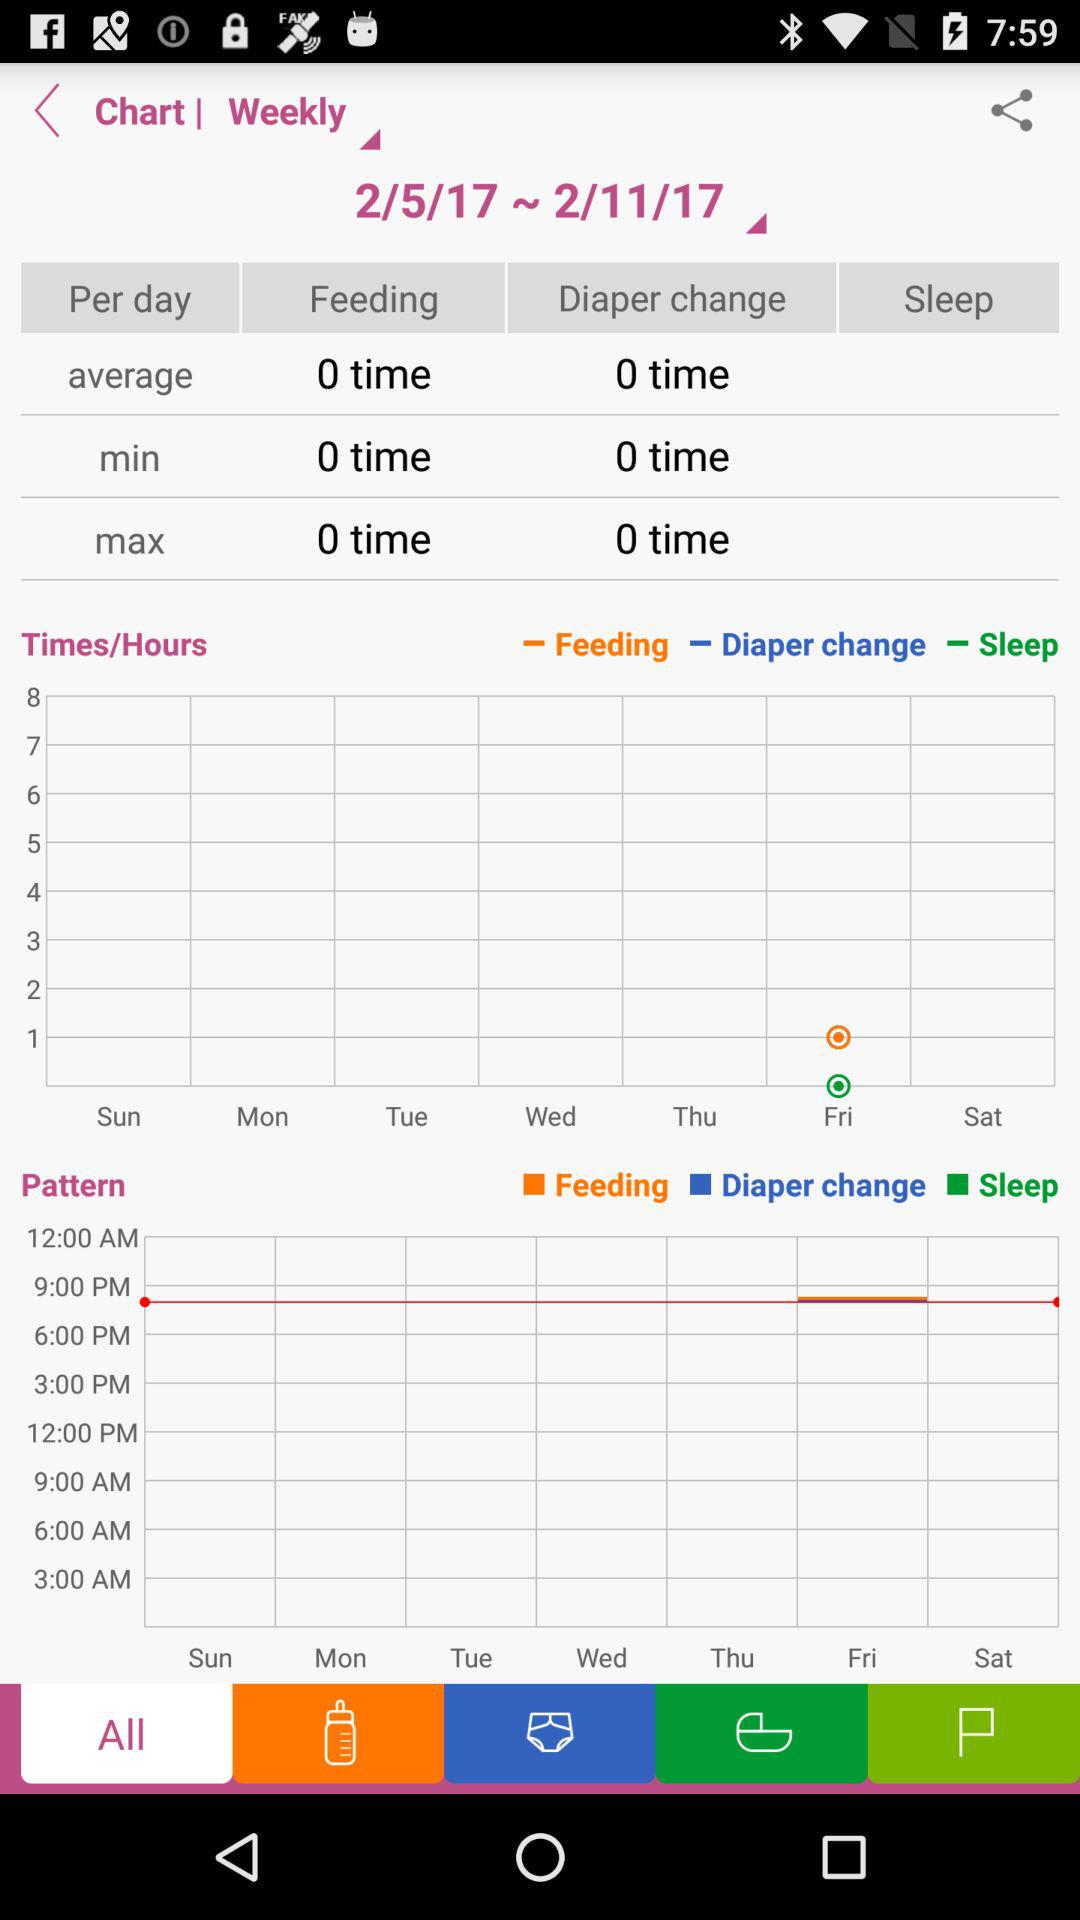What type of chart is selected? The selected chart type is "Weekly". 